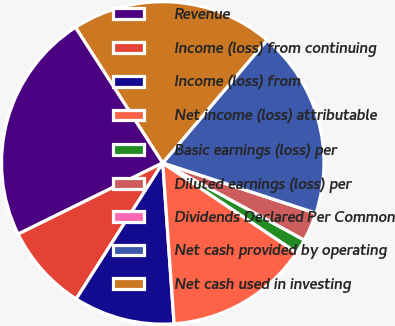Convert chart to OTSL. <chart><loc_0><loc_0><loc_500><loc_500><pie_chart><fcel>Revenue<fcel>Income (loss) from continuing<fcel>Income (loss) from<fcel>Net income (loss) attributable<fcel>Basic earnings (loss) per<fcel>Diluted earnings (loss) per<fcel>Dividends Declared Per Common<fcel>Net cash provided by operating<fcel>Net cash used in investing<nl><fcel>23.19%<fcel>8.7%<fcel>10.14%<fcel>14.49%<fcel>1.45%<fcel>2.9%<fcel>0.0%<fcel>18.84%<fcel>20.29%<nl></chart> 